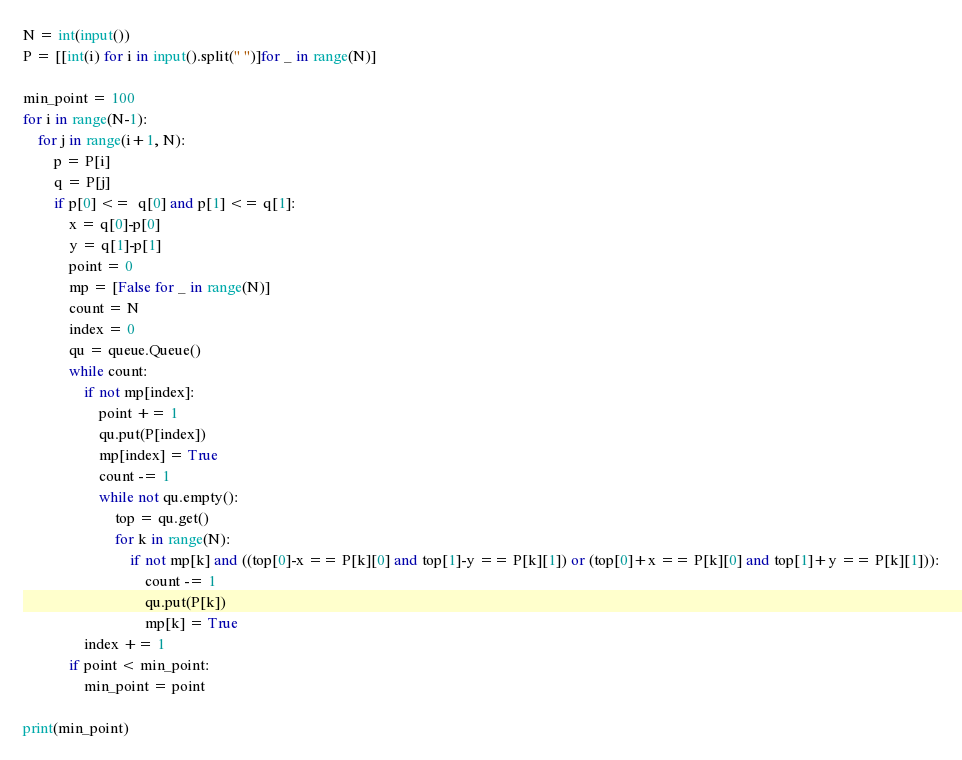Convert code to text. <code><loc_0><loc_0><loc_500><loc_500><_Python_>
N = int(input())
P = [[int(i) for i in input().split(" ")]for _ in range(N)]

min_point = 100
for i in range(N-1):
	for j in range(i+1, N):
		p = P[i]
		q = P[j]
		if p[0] <=  q[0] and p[1] <= q[1]:
			x = q[0]-p[0]
			y = q[1]-p[1]
			point = 0
			mp = [False for _ in range(N)]
			count = N
			index = 0
			qu = queue.Queue()
			while count:
				if not mp[index]:
					point += 1
					qu.put(P[index])
					mp[index] = True
					count -= 1
					while not qu.empty():
						top = qu.get()
						for k in range(N):
							if not mp[k] and ((top[0]-x == P[k][0] and top[1]-y == P[k][1]) or (top[0]+x == P[k][0] and top[1]+y == P[k][1])):
								count -= 1
								qu.put(P[k])
								mp[k] = True
				index += 1
			if point < min_point:
				min_point = point

print(min_point)


</code> 